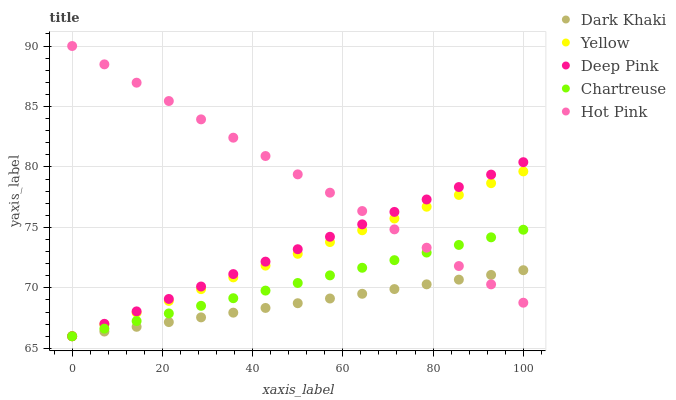Does Dark Khaki have the minimum area under the curve?
Answer yes or no. Yes. Does Hot Pink have the maximum area under the curve?
Answer yes or no. Yes. Does Chartreuse have the minimum area under the curve?
Answer yes or no. No. Does Chartreuse have the maximum area under the curve?
Answer yes or no. No. Is Chartreuse the smoothest?
Answer yes or no. Yes. Is Dark Khaki the roughest?
Answer yes or no. Yes. Is Deep Pink the smoothest?
Answer yes or no. No. Is Deep Pink the roughest?
Answer yes or no. No. Does Dark Khaki have the lowest value?
Answer yes or no. Yes. Does Hot Pink have the lowest value?
Answer yes or no. No. Does Hot Pink have the highest value?
Answer yes or no. Yes. Does Chartreuse have the highest value?
Answer yes or no. No. Does Hot Pink intersect Chartreuse?
Answer yes or no. Yes. Is Hot Pink less than Chartreuse?
Answer yes or no. No. Is Hot Pink greater than Chartreuse?
Answer yes or no. No. 